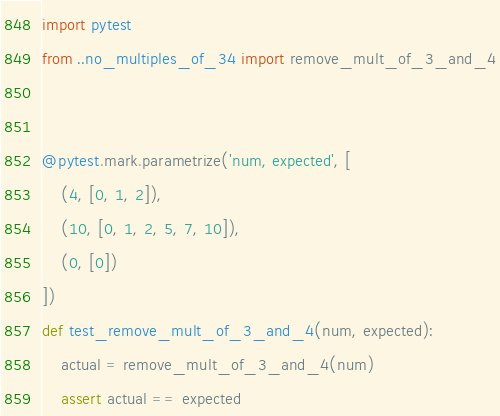<code> <loc_0><loc_0><loc_500><loc_500><_Python_>import pytest
from ..no_multiples_of_34 import remove_mult_of_3_and_4


@pytest.mark.parametrize('num, expected', [
    (4, [0, 1, 2]),
    (10, [0, 1, 2, 5, 7, 10]),
    (0, [0])
])
def test_remove_mult_of_3_and_4(num, expected):
    actual = remove_mult_of_3_and_4(num)
    assert actual == expected
</code> 